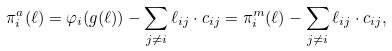Convert formula to latex. <formula><loc_0><loc_0><loc_500><loc_500>\pi _ { i } ^ { a } ( \ell ) = \varphi _ { i } ( g ( \ell ) ) - \sum _ { j \neq i } \ell _ { i j } \cdot c _ { i j } = \pi ^ { m } _ { i } ( \ell ) - \sum _ { j \neq i } \ell _ { i j } \cdot c _ { i j } ,</formula> 